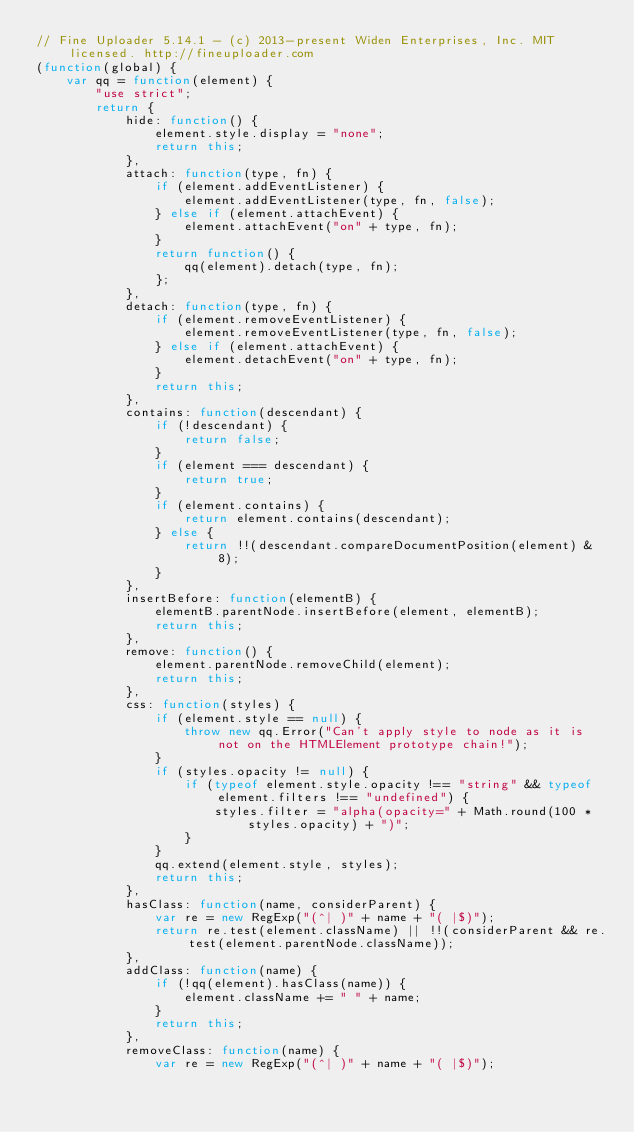Convert code to text. <code><loc_0><loc_0><loc_500><loc_500><_JavaScript_>// Fine Uploader 5.14.1 - (c) 2013-present Widen Enterprises, Inc. MIT licensed. http://fineuploader.com
(function(global) {
    var qq = function(element) {
        "use strict";
        return {
            hide: function() {
                element.style.display = "none";
                return this;
            },
            attach: function(type, fn) {
                if (element.addEventListener) {
                    element.addEventListener(type, fn, false);
                } else if (element.attachEvent) {
                    element.attachEvent("on" + type, fn);
                }
                return function() {
                    qq(element).detach(type, fn);
                };
            },
            detach: function(type, fn) {
                if (element.removeEventListener) {
                    element.removeEventListener(type, fn, false);
                } else if (element.attachEvent) {
                    element.detachEvent("on" + type, fn);
                }
                return this;
            },
            contains: function(descendant) {
                if (!descendant) {
                    return false;
                }
                if (element === descendant) {
                    return true;
                }
                if (element.contains) {
                    return element.contains(descendant);
                } else {
                    return !!(descendant.compareDocumentPosition(element) & 8);
                }
            },
            insertBefore: function(elementB) {
                elementB.parentNode.insertBefore(element, elementB);
                return this;
            },
            remove: function() {
                element.parentNode.removeChild(element);
                return this;
            },
            css: function(styles) {
                if (element.style == null) {
                    throw new qq.Error("Can't apply style to node as it is not on the HTMLElement prototype chain!");
                }
                if (styles.opacity != null) {
                    if (typeof element.style.opacity !== "string" && typeof element.filters !== "undefined") {
                        styles.filter = "alpha(opacity=" + Math.round(100 * styles.opacity) + ")";
                    }
                }
                qq.extend(element.style, styles);
                return this;
            },
            hasClass: function(name, considerParent) {
                var re = new RegExp("(^| )" + name + "( |$)");
                return re.test(element.className) || !!(considerParent && re.test(element.parentNode.className));
            },
            addClass: function(name) {
                if (!qq(element).hasClass(name)) {
                    element.className += " " + name;
                }
                return this;
            },
            removeClass: function(name) {
                var re = new RegExp("(^| )" + name + "( |$)");</code> 